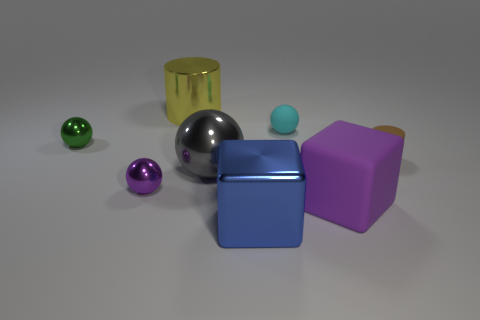There is a tiny cyan object that is the same shape as the gray shiny thing; what is its material?
Your answer should be compact. Rubber. Is there any other thing that is the same material as the big ball?
Offer a very short reply. Yes. Are there any tiny matte objects in front of the purple metallic object?
Your answer should be very brief. No. What number of cyan metal things are there?
Provide a succinct answer. 0. How many small cyan things are on the left side of the purple thing that is to the left of the big blue block?
Offer a very short reply. 0. There is a big matte thing; is it the same color as the cylinder that is on the right side of the big metal cube?
Offer a very short reply. No. What number of purple rubber things are the same shape as the small brown matte object?
Offer a terse response. 0. There is a small thing in front of the brown rubber cylinder; what material is it?
Your answer should be very brief. Metal. Does the small shiny thing in front of the brown thing have the same shape as the small brown matte thing?
Offer a terse response. No. Is there a purple matte thing that has the same size as the purple metallic thing?
Give a very brief answer. No. 